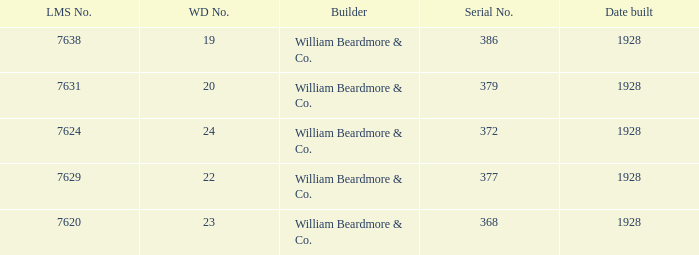Name the lms number for serial number being 372 7624.0. 